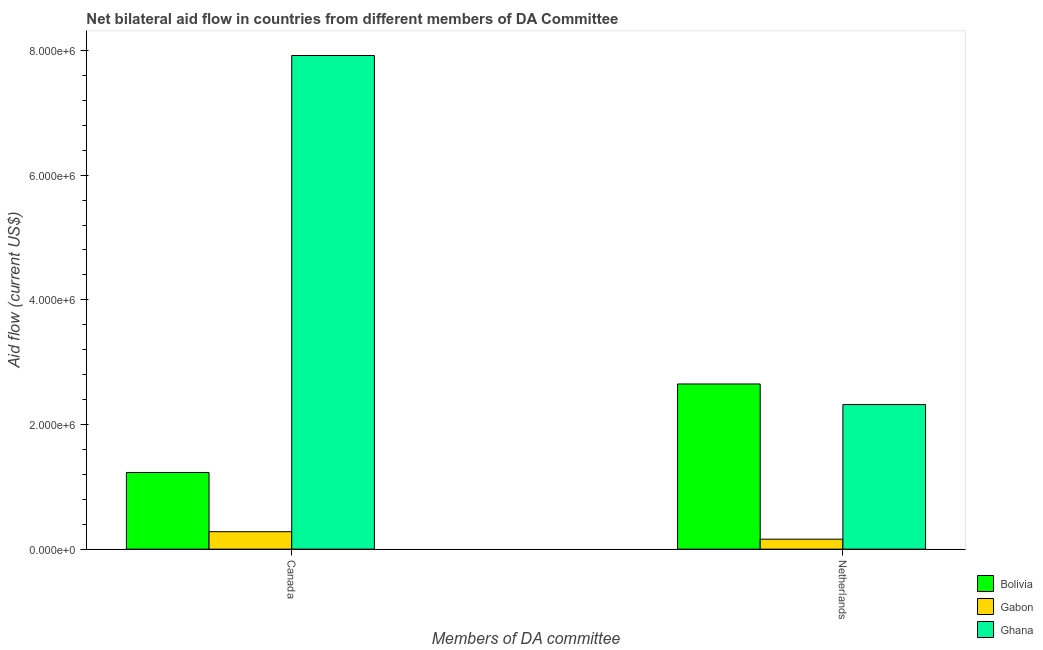How many groups of bars are there?
Offer a very short reply. 2. Are the number of bars per tick equal to the number of legend labels?
Keep it short and to the point. Yes. Are the number of bars on each tick of the X-axis equal?
Your answer should be very brief. Yes. How many bars are there on the 2nd tick from the left?
Offer a terse response. 3. What is the label of the 2nd group of bars from the left?
Keep it short and to the point. Netherlands. What is the amount of aid given by canada in Ghana?
Provide a short and direct response. 7.92e+06. Across all countries, what is the maximum amount of aid given by canada?
Your response must be concise. 7.92e+06. Across all countries, what is the minimum amount of aid given by canada?
Provide a short and direct response. 2.80e+05. In which country was the amount of aid given by netherlands maximum?
Offer a terse response. Bolivia. In which country was the amount of aid given by netherlands minimum?
Provide a short and direct response. Gabon. What is the total amount of aid given by canada in the graph?
Give a very brief answer. 9.43e+06. What is the difference between the amount of aid given by netherlands in Gabon and that in Ghana?
Offer a very short reply. -2.16e+06. What is the difference between the amount of aid given by canada in Gabon and the amount of aid given by netherlands in Ghana?
Give a very brief answer. -2.04e+06. What is the average amount of aid given by canada per country?
Make the answer very short. 3.14e+06. What is the difference between the amount of aid given by netherlands and amount of aid given by canada in Bolivia?
Offer a terse response. 1.42e+06. What is the ratio of the amount of aid given by netherlands in Gabon to that in Ghana?
Ensure brevity in your answer.  0.07. Is the amount of aid given by netherlands in Ghana less than that in Bolivia?
Ensure brevity in your answer.  Yes. What does the 2nd bar from the left in Netherlands represents?
Give a very brief answer. Gabon. What does the 1st bar from the right in Netherlands represents?
Your answer should be compact. Ghana. Are the values on the major ticks of Y-axis written in scientific E-notation?
Offer a very short reply. Yes. Does the graph contain grids?
Provide a succinct answer. No. Where does the legend appear in the graph?
Ensure brevity in your answer.  Bottom right. How many legend labels are there?
Make the answer very short. 3. What is the title of the graph?
Provide a succinct answer. Net bilateral aid flow in countries from different members of DA Committee. Does "Heavily indebted poor countries" appear as one of the legend labels in the graph?
Ensure brevity in your answer.  No. What is the label or title of the X-axis?
Keep it short and to the point. Members of DA committee. What is the label or title of the Y-axis?
Offer a terse response. Aid flow (current US$). What is the Aid flow (current US$) in Bolivia in Canada?
Provide a short and direct response. 1.23e+06. What is the Aid flow (current US$) in Ghana in Canada?
Provide a succinct answer. 7.92e+06. What is the Aid flow (current US$) in Bolivia in Netherlands?
Make the answer very short. 2.65e+06. What is the Aid flow (current US$) of Gabon in Netherlands?
Provide a short and direct response. 1.60e+05. What is the Aid flow (current US$) in Ghana in Netherlands?
Keep it short and to the point. 2.32e+06. Across all Members of DA committee, what is the maximum Aid flow (current US$) in Bolivia?
Offer a terse response. 2.65e+06. Across all Members of DA committee, what is the maximum Aid flow (current US$) in Gabon?
Provide a short and direct response. 2.80e+05. Across all Members of DA committee, what is the maximum Aid flow (current US$) of Ghana?
Give a very brief answer. 7.92e+06. Across all Members of DA committee, what is the minimum Aid flow (current US$) in Bolivia?
Ensure brevity in your answer.  1.23e+06. Across all Members of DA committee, what is the minimum Aid flow (current US$) of Gabon?
Keep it short and to the point. 1.60e+05. Across all Members of DA committee, what is the minimum Aid flow (current US$) in Ghana?
Your answer should be very brief. 2.32e+06. What is the total Aid flow (current US$) of Bolivia in the graph?
Your answer should be very brief. 3.88e+06. What is the total Aid flow (current US$) of Gabon in the graph?
Your response must be concise. 4.40e+05. What is the total Aid flow (current US$) of Ghana in the graph?
Your answer should be compact. 1.02e+07. What is the difference between the Aid flow (current US$) of Bolivia in Canada and that in Netherlands?
Your answer should be compact. -1.42e+06. What is the difference between the Aid flow (current US$) in Gabon in Canada and that in Netherlands?
Provide a succinct answer. 1.20e+05. What is the difference between the Aid flow (current US$) of Ghana in Canada and that in Netherlands?
Your answer should be very brief. 5.60e+06. What is the difference between the Aid flow (current US$) in Bolivia in Canada and the Aid flow (current US$) in Gabon in Netherlands?
Give a very brief answer. 1.07e+06. What is the difference between the Aid flow (current US$) of Bolivia in Canada and the Aid flow (current US$) of Ghana in Netherlands?
Offer a very short reply. -1.09e+06. What is the difference between the Aid flow (current US$) in Gabon in Canada and the Aid flow (current US$) in Ghana in Netherlands?
Provide a succinct answer. -2.04e+06. What is the average Aid flow (current US$) of Bolivia per Members of DA committee?
Your answer should be compact. 1.94e+06. What is the average Aid flow (current US$) of Gabon per Members of DA committee?
Provide a succinct answer. 2.20e+05. What is the average Aid flow (current US$) of Ghana per Members of DA committee?
Your answer should be very brief. 5.12e+06. What is the difference between the Aid flow (current US$) in Bolivia and Aid flow (current US$) in Gabon in Canada?
Your answer should be compact. 9.50e+05. What is the difference between the Aid flow (current US$) in Bolivia and Aid flow (current US$) in Ghana in Canada?
Keep it short and to the point. -6.69e+06. What is the difference between the Aid flow (current US$) of Gabon and Aid flow (current US$) of Ghana in Canada?
Your response must be concise. -7.64e+06. What is the difference between the Aid flow (current US$) in Bolivia and Aid flow (current US$) in Gabon in Netherlands?
Your answer should be compact. 2.49e+06. What is the difference between the Aid flow (current US$) of Bolivia and Aid flow (current US$) of Ghana in Netherlands?
Ensure brevity in your answer.  3.30e+05. What is the difference between the Aid flow (current US$) in Gabon and Aid flow (current US$) in Ghana in Netherlands?
Give a very brief answer. -2.16e+06. What is the ratio of the Aid flow (current US$) in Bolivia in Canada to that in Netherlands?
Your answer should be compact. 0.46. What is the ratio of the Aid flow (current US$) in Gabon in Canada to that in Netherlands?
Your answer should be compact. 1.75. What is the ratio of the Aid flow (current US$) in Ghana in Canada to that in Netherlands?
Make the answer very short. 3.41. What is the difference between the highest and the second highest Aid flow (current US$) in Bolivia?
Make the answer very short. 1.42e+06. What is the difference between the highest and the second highest Aid flow (current US$) of Ghana?
Keep it short and to the point. 5.60e+06. What is the difference between the highest and the lowest Aid flow (current US$) in Bolivia?
Keep it short and to the point. 1.42e+06. What is the difference between the highest and the lowest Aid flow (current US$) of Ghana?
Provide a short and direct response. 5.60e+06. 